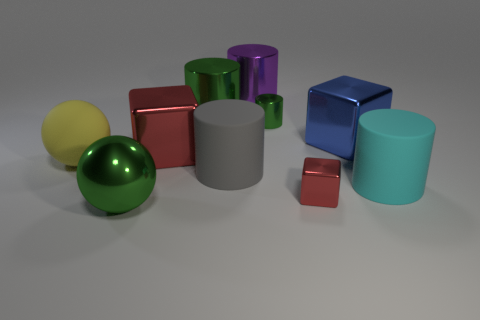There is a large cyan cylinder; how many metallic cylinders are in front of it?
Your answer should be very brief. 0. Are there any shiny cubes?
Ensure brevity in your answer.  Yes. What color is the tiny object that is in front of the big metal thing that is right of the small red shiny cube that is to the right of the big yellow rubber object?
Give a very brief answer. Red. Is there a big sphere in front of the big object left of the large green ball?
Ensure brevity in your answer.  Yes. There is a metal cube that is in front of the big gray object; is its color the same as the cylinder right of the large blue block?
Your answer should be very brief. No. How many purple cylinders have the same size as the yellow object?
Make the answer very short. 1. There is a ball to the left of the green metal sphere; is it the same size as the blue metal object?
Ensure brevity in your answer.  Yes. The large gray thing has what shape?
Give a very brief answer. Cylinder. What is the size of the object that is the same color as the small cube?
Your answer should be compact. Large. Do the green thing in front of the big yellow rubber object and the large cyan thing have the same material?
Your response must be concise. No. 